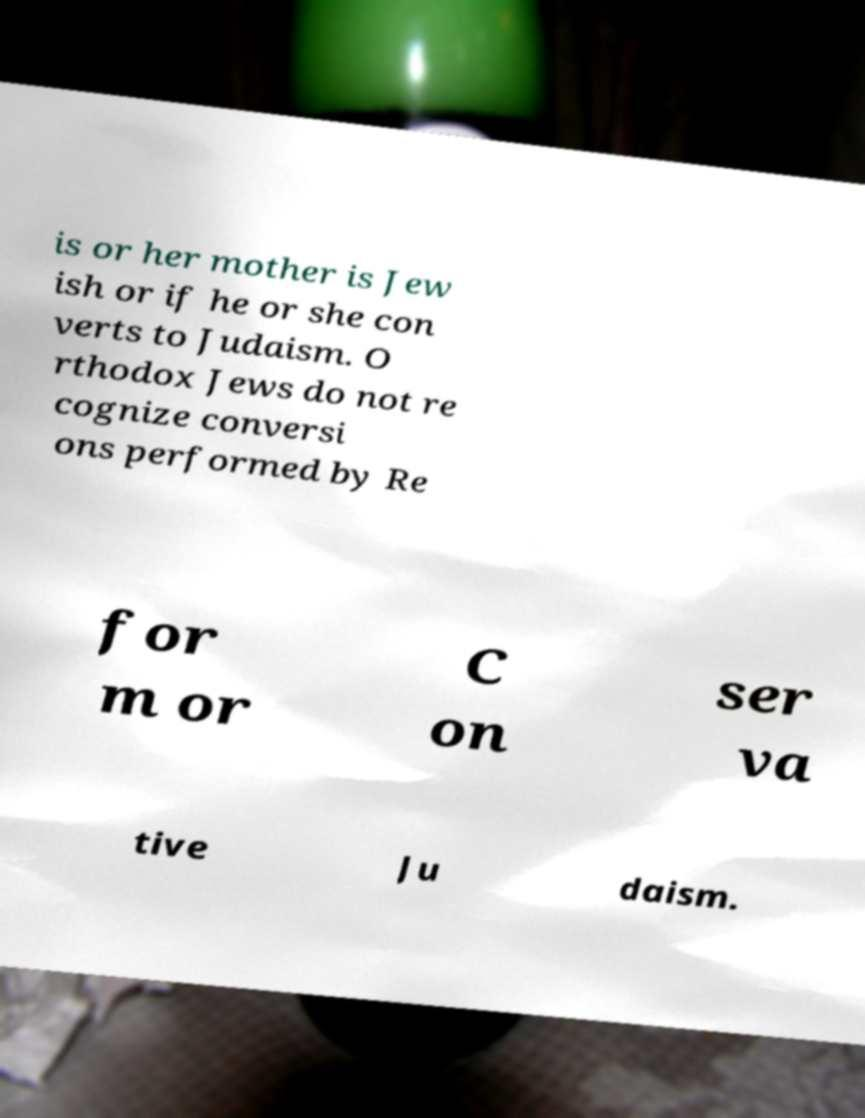Please read and relay the text visible in this image. What does it say? is or her mother is Jew ish or if he or she con verts to Judaism. O rthodox Jews do not re cognize conversi ons performed by Re for m or C on ser va tive Ju daism. 